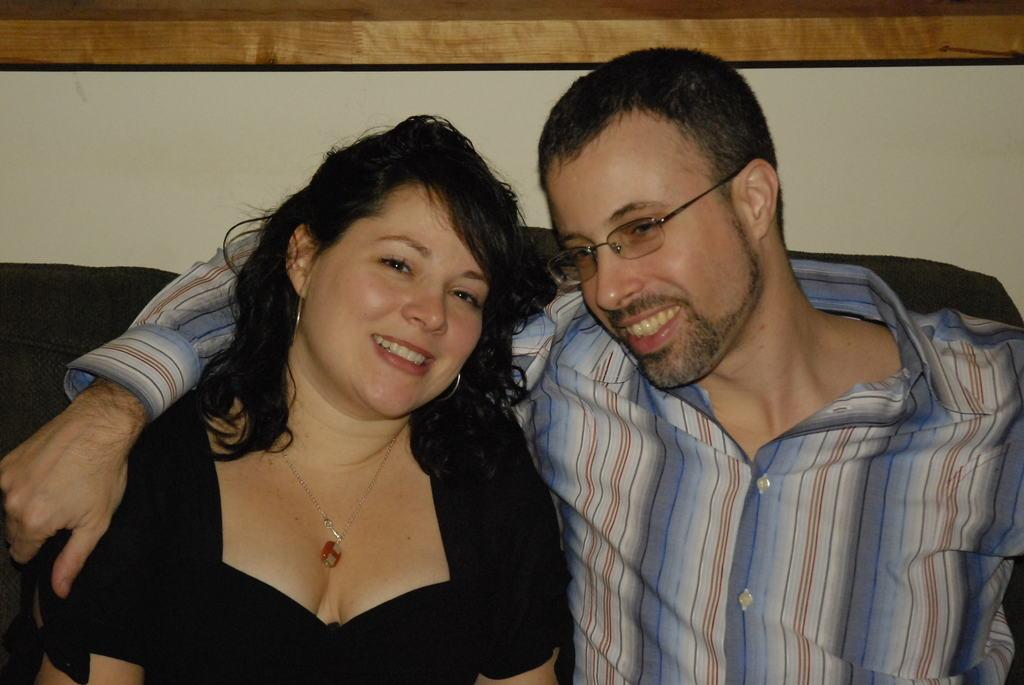How many people are in the image? There are two people in the image. What are the two people doing in the image? The two people are sitting on a couch. Can you describe the appearance of one of the individuals? The man is wearing spectacles. What can be seen in the background of the image? There is a wall in the background of the image. What type of amusement can be seen in the image? There is no amusement present in the image; it features two people sitting on a couch. How does the clam contribute to the conversation in the image? There is no clam present in the image, so it cannot contribute to the conversation. 